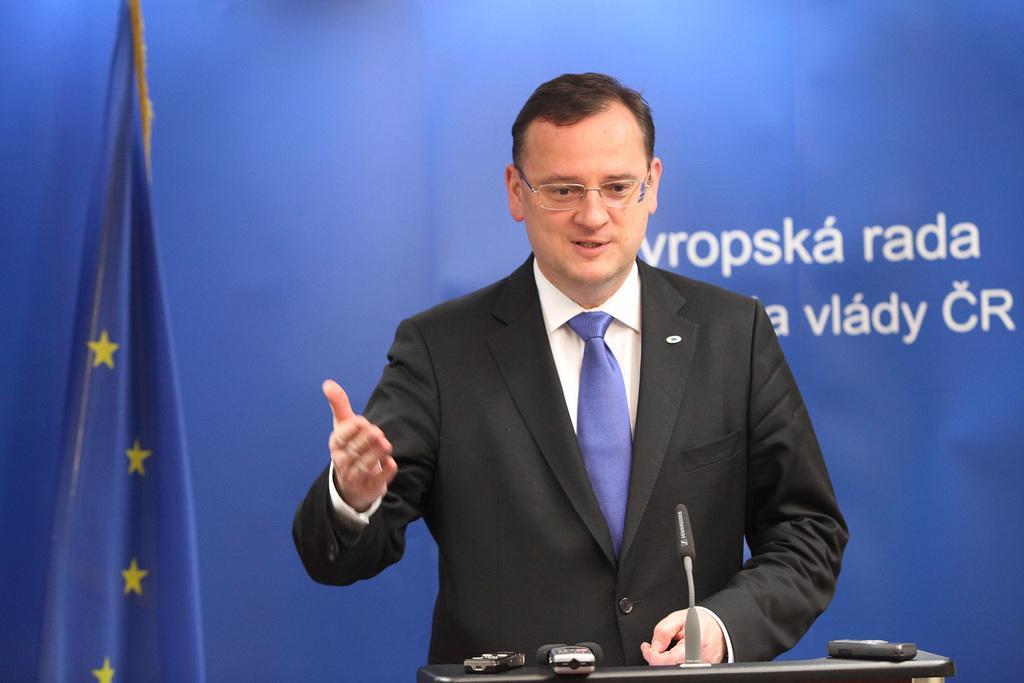How would you summarize this image in a sentence or two? In this image, we can see a person in a suit is talking and wearing glasses. At the bottom, we can see black object, few objects are placed on it. Background there is a banner. Here we can see some text. Left side of the image, there is a flag. 